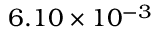<formula> <loc_0><loc_0><loc_500><loc_500>6 . 1 0 \times 1 0 ^ { - 3 }</formula> 